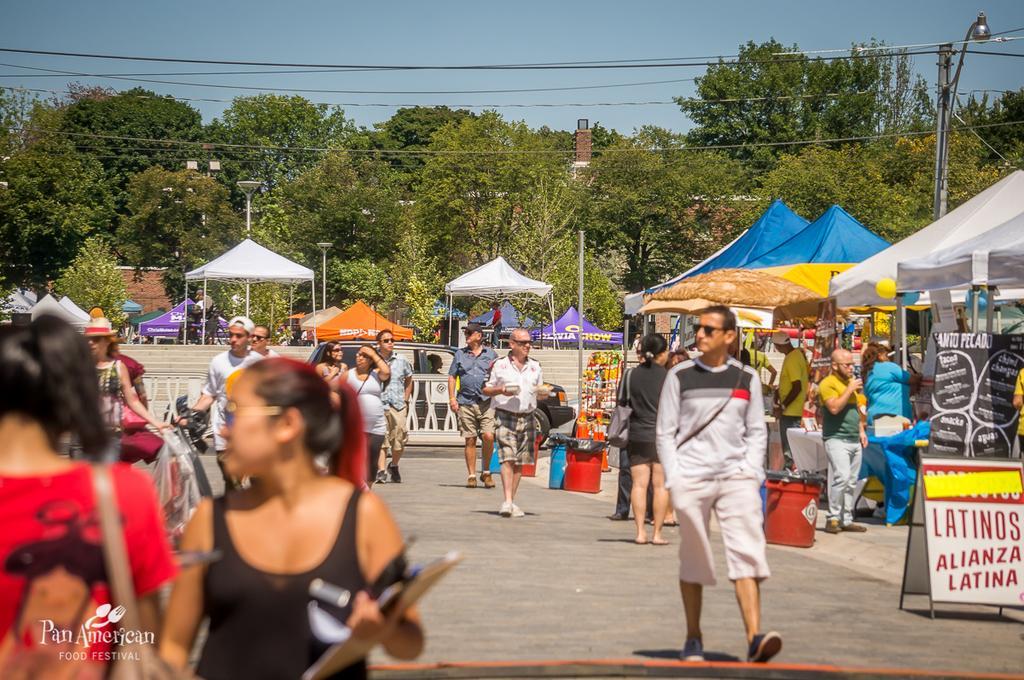Describe this image in one or two sentences. In this image there is a road on which there are so many people. On the right side there are tents under which there are shops. In the background there are trees. On the right side there is a pole to which there is a light. At the top there are wires. 